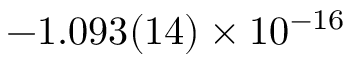Convert formula to latex. <formula><loc_0><loc_0><loc_500><loc_500>- 1 . 0 9 3 ( 1 4 ) \times 1 0 ^ { - 1 6 }</formula> 